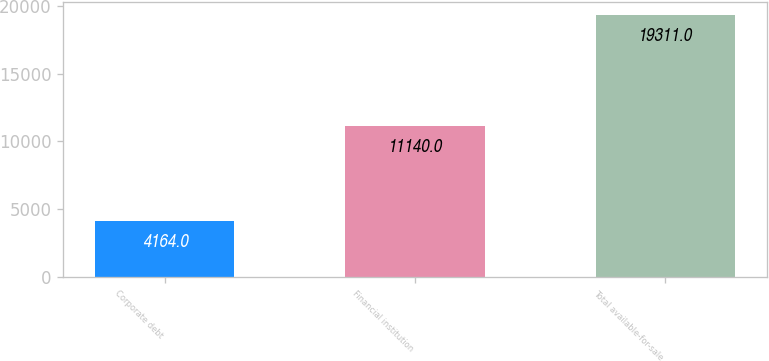Convert chart to OTSL. <chart><loc_0><loc_0><loc_500><loc_500><bar_chart><fcel>Corporate debt<fcel>Financial institution<fcel>Total available-for-sale<nl><fcel>4164<fcel>11140<fcel>19311<nl></chart> 